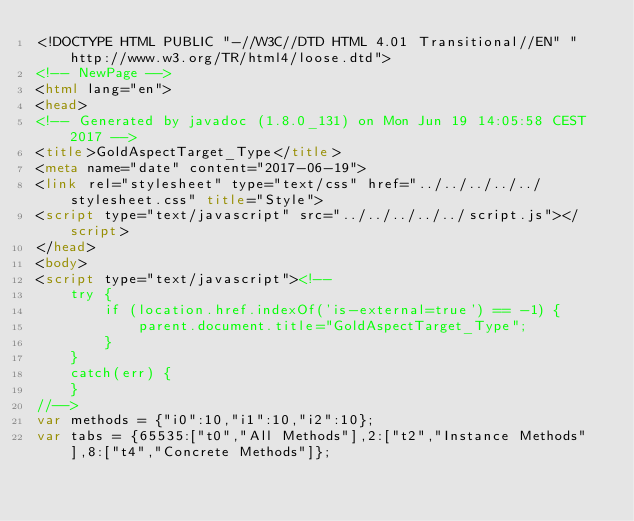<code> <loc_0><loc_0><loc_500><loc_500><_HTML_><!DOCTYPE HTML PUBLIC "-//W3C//DTD HTML 4.01 Transitional//EN" "http://www.w3.org/TR/html4/loose.dtd">
<!-- NewPage -->
<html lang="en">
<head>
<!-- Generated by javadoc (1.8.0_131) on Mon Jun 19 14:05:58 CEST 2017 -->
<title>GoldAspectTarget_Type</title>
<meta name="date" content="2017-06-19">
<link rel="stylesheet" type="text/css" href="../../../../../stylesheet.css" title="Style">
<script type="text/javascript" src="../../../../../script.js"></script>
</head>
<body>
<script type="text/javascript"><!--
    try {
        if (location.href.indexOf('is-external=true') == -1) {
            parent.document.title="GoldAspectTarget_Type";
        }
    }
    catch(err) {
    }
//-->
var methods = {"i0":10,"i1":10,"i2":10};
var tabs = {65535:["t0","All Methods"],2:["t2","Instance Methods"],8:["t4","Concrete Methods"]};</code> 